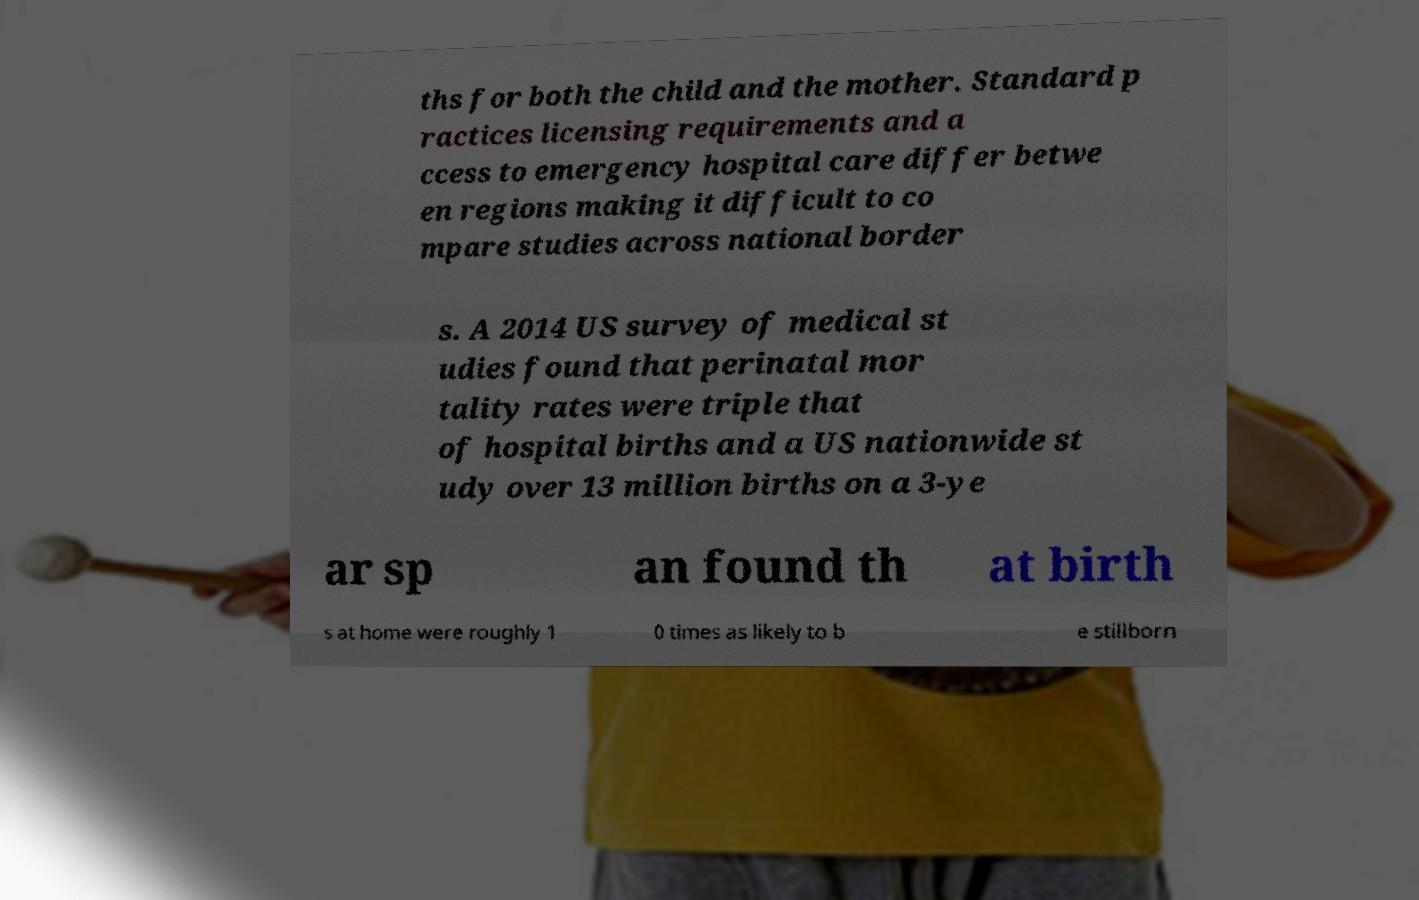Could you assist in decoding the text presented in this image and type it out clearly? ths for both the child and the mother. Standard p ractices licensing requirements and a ccess to emergency hospital care differ betwe en regions making it difficult to co mpare studies across national border s. A 2014 US survey of medical st udies found that perinatal mor tality rates were triple that of hospital births and a US nationwide st udy over 13 million births on a 3-ye ar sp an found th at birth s at home were roughly 1 0 times as likely to b e stillborn 